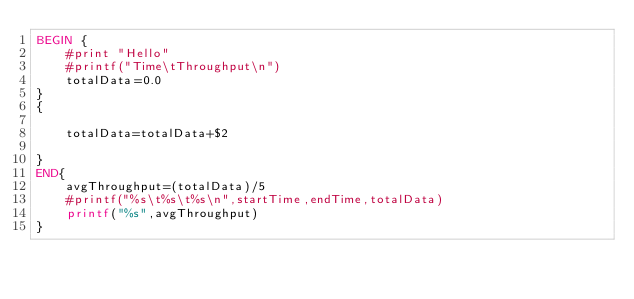<code> <loc_0><loc_0><loc_500><loc_500><_Awk_>BEGIN {
	#print "Hello"
	#printf("Time\tThroughput\n")
	totalData=0.0
}
{	
	
	totalData=totalData+$2
	
}
END{
	avgThroughput=(totalData)/5
	#printf("%s\t%s\t%s\n",startTime,endTime,totalData)
	printf("%s",avgThroughput)
}
</code> 